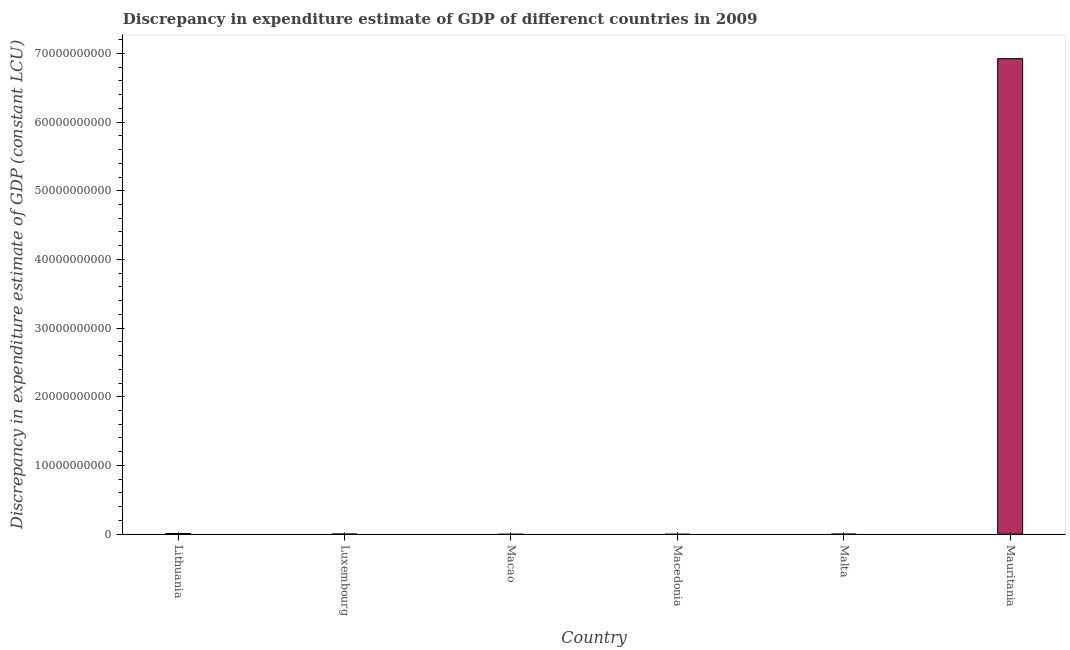Does the graph contain any zero values?
Give a very brief answer. Yes. What is the title of the graph?
Your answer should be compact. Discrepancy in expenditure estimate of GDP of differenct countries in 2009. What is the label or title of the Y-axis?
Offer a very short reply. Discrepancy in expenditure estimate of GDP (constant LCU). What is the discrepancy in expenditure estimate of gdp in Luxembourg?
Provide a succinct answer. 0. Across all countries, what is the maximum discrepancy in expenditure estimate of gdp?
Give a very brief answer. 6.92e+1. Across all countries, what is the minimum discrepancy in expenditure estimate of gdp?
Keep it short and to the point. 0. In which country was the discrepancy in expenditure estimate of gdp maximum?
Your answer should be compact. Mauritania. What is the sum of the discrepancy in expenditure estimate of gdp?
Offer a very short reply. 6.93e+1. What is the average discrepancy in expenditure estimate of gdp per country?
Make the answer very short. 1.16e+1. Is the sum of the discrepancy in expenditure estimate of gdp in Lithuania and Mauritania greater than the maximum discrepancy in expenditure estimate of gdp across all countries?
Ensure brevity in your answer.  Yes. What is the difference between the highest and the lowest discrepancy in expenditure estimate of gdp?
Your response must be concise. 6.92e+1. In how many countries, is the discrepancy in expenditure estimate of gdp greater than the average discrepancy in expenditure estimate of gdp taken over all countries?
Provide a succinct answer. 1. How many bars are there?
Make the answer very short. 2. Are the values on the major ticks of Y-axis written in scientific E-notation?
Offer a terse response. No. What is the Discrepancy in expenditure estimate of GDP (constant LCU) of Lithuania?
Your answer should be very brief. 9.07e+07. What is the Discrepancy in expenditure estimate of GDP (constant LCU) of Luxembourg?
Offer a very short reply. 0. What is the Discrepancy in expenditure estimate of GDP (constant LCU) of Macao?
Your answer should be compact. 0. What is the Discrepancy in expenditure estimate of GDP (constant LCU) of Macedonia?
Keep it short and to the point. 0. What is the Discrepancy in expenditure estimate of GDP (constant LCU) in Mauritania?
Your response must be concise. 6.92e+1. What is the difference between the Discrepancy in expenditure estimate of GDP (constant LCU) in Lithuania and Mauritania?
Give a very brief answer. -6.91e+1. 